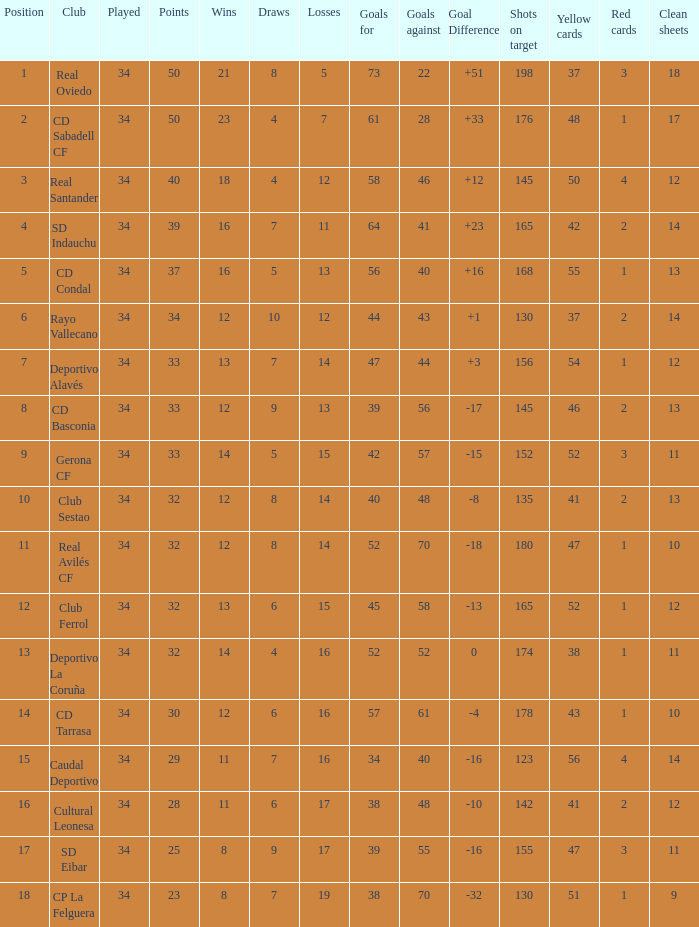How many Goals against have Played more than 34? 0.0. 